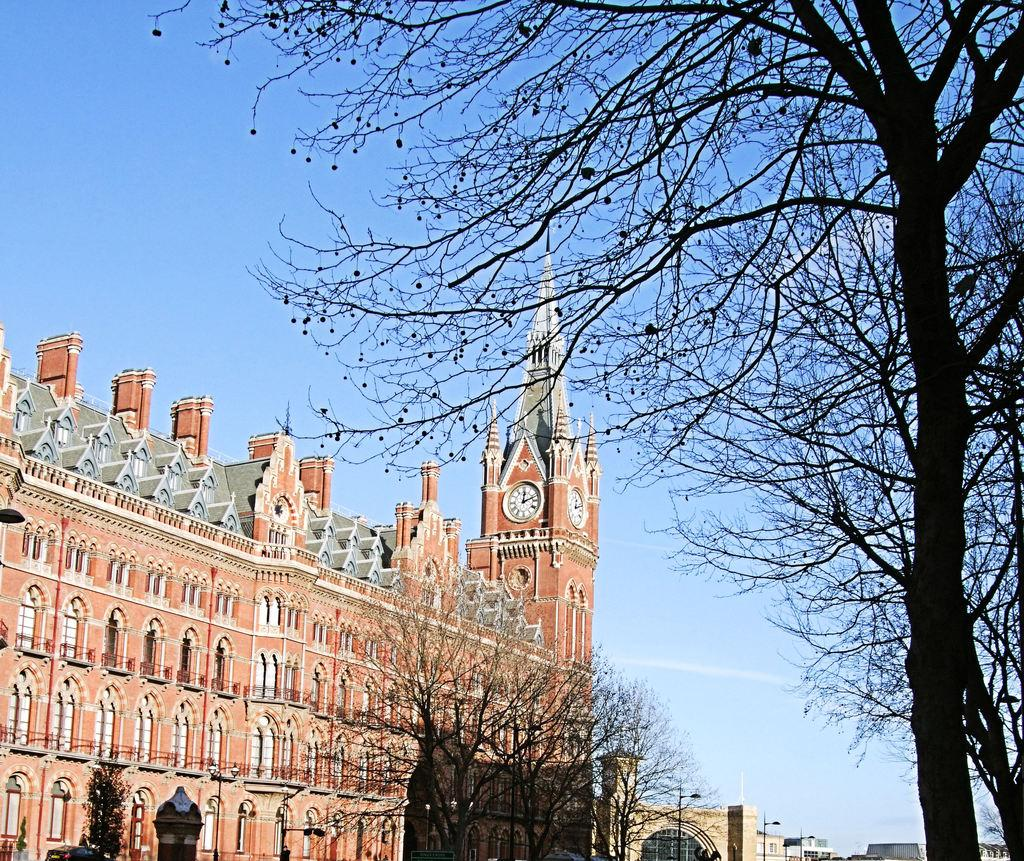What type of vegetation is on the right side of the image? There are bare trees on the right side of the image. What can be seen in the background of the image? Buildings, street lights, poles, windows, and a clock on a wall are present in the background of the image. What is visible in the sky in the background of the image? Clouds are visible in the sky in the background of the image. What type of brain can be seen in the image? There is no brain present in the image. What effect does the clock on the wall have on the street lights? The clock on the wall does not have any effect on the street lights in the image. 